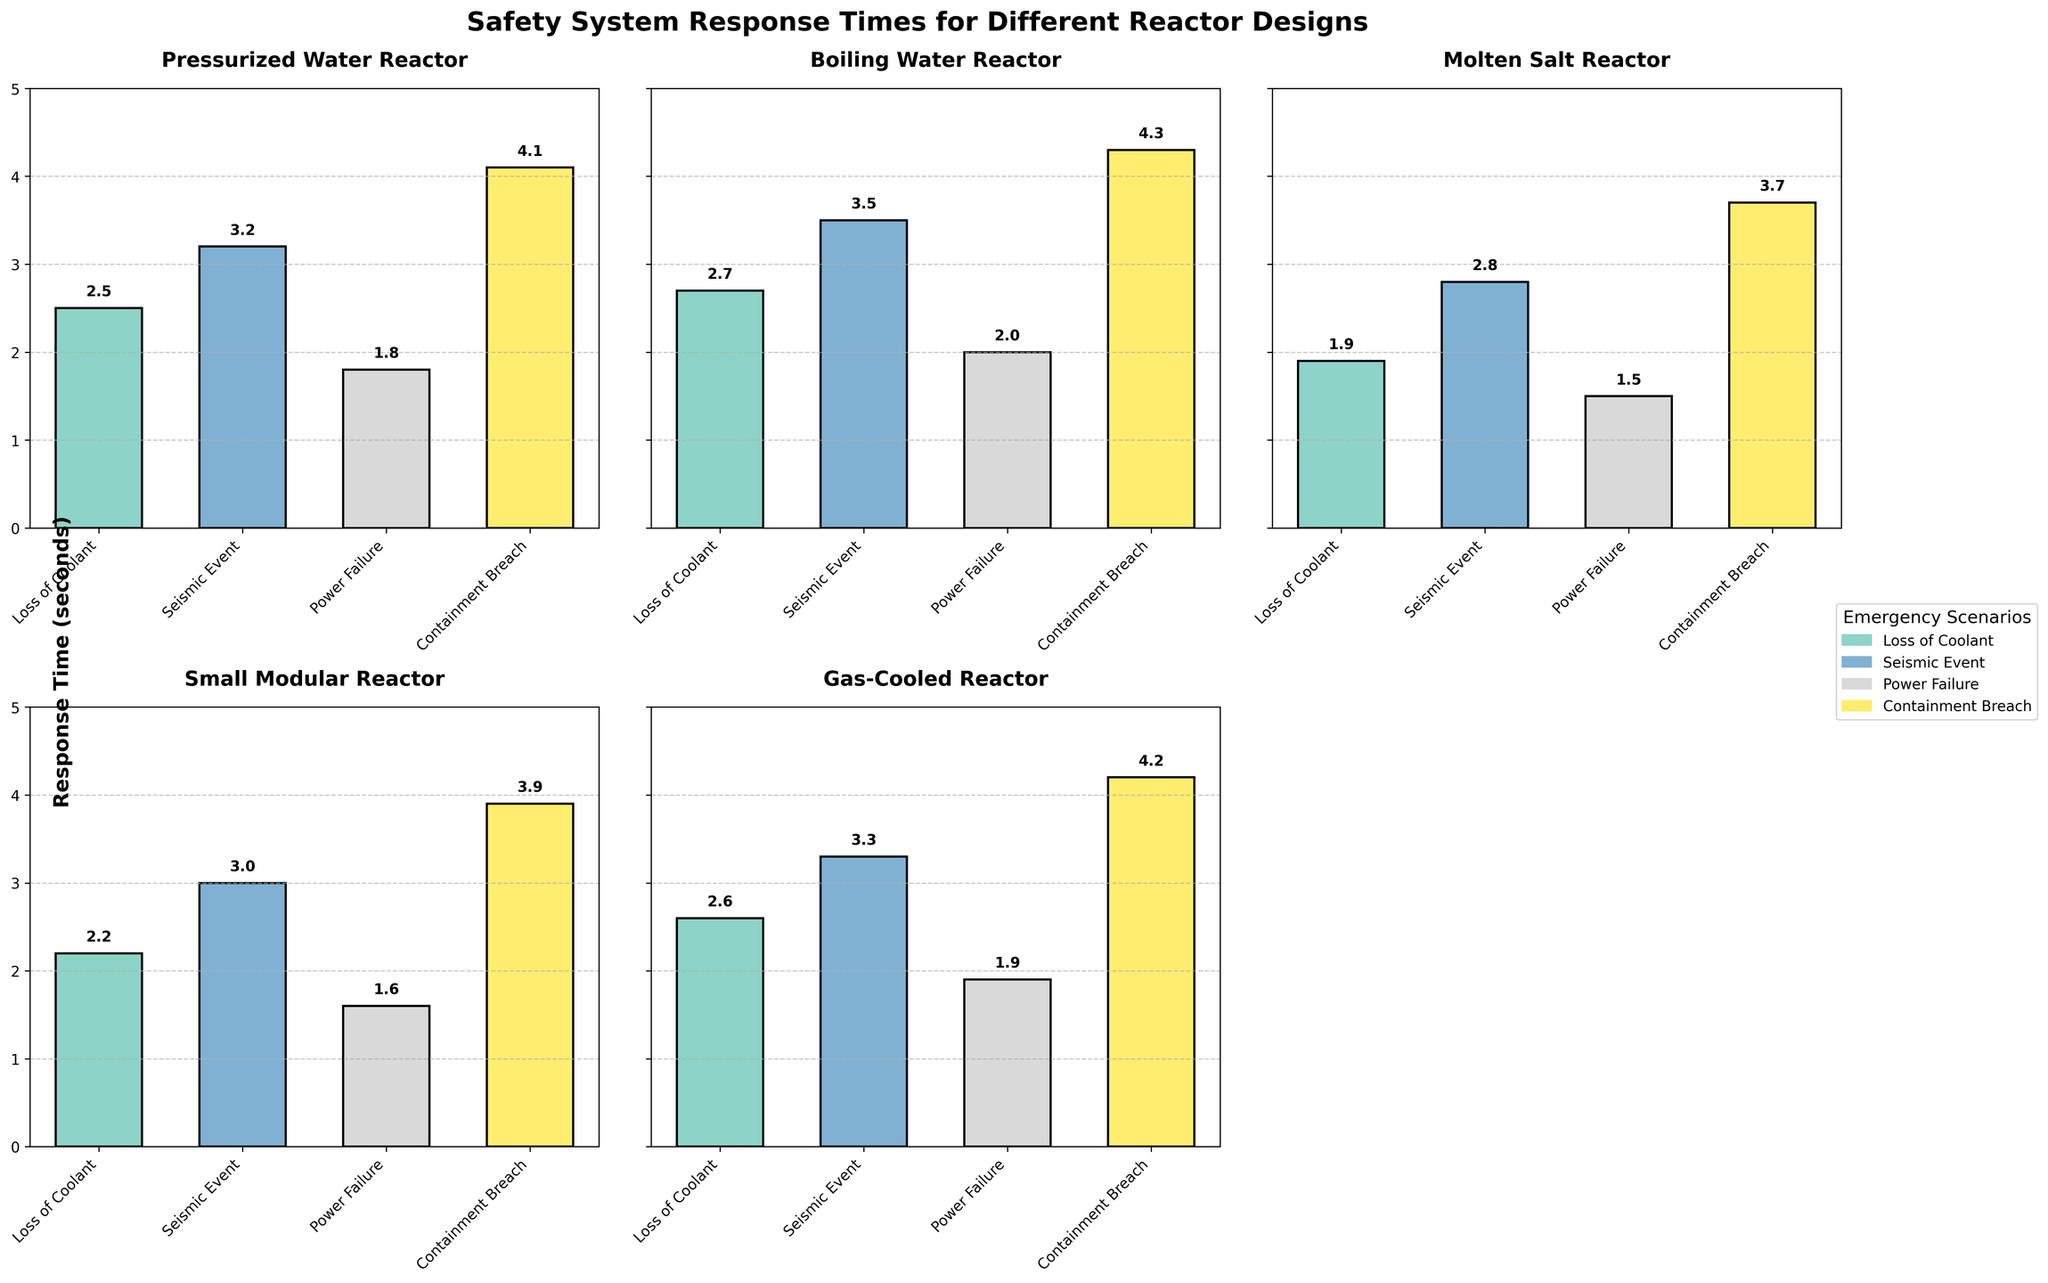Which reactor design has the fastest response time for a loss of coolant scenario? Locate the "Loss of Coolant" bar for each reactor design and find the design with the shortest bar, indicating the lowest response time.
Answer: Molten Salt Reactor Which reactor design has the slowest response time for a containment breach? Find the "Containment Breach" bar for each reactor design and compare their lengths to identify the highest bar, indicating the longest response time.
Answer: Boiling Water Reactor What is the difference in response times between the Seismic Event and Containment Breach scenarios for the Small Modular Reactor? Refer to the Small Modular Reactor subplot, get the heights of the "Seismic Event" and "Containment Breach" bars, and subtract the former from the latter. These heights are 3.0 and 3.9 seconds respectively. Perform the subtraction: 3.9 - 3.0 = 0.9.
Answer: 0.9 seconds Which emergency scenario has the highest overall response time across all reactor designs? Compare the bars labeled for each emergency scenario across all subplots. "Containment Breach" consistently shows the highest bars across the designs.
Answer: Containment Breach What is the average response time for a Power Failure scenario across all reactor designs? Extract the "Power Failure" values from each subplot: 1.8, 2.0, 1.5, 1.6, 1.9, 1.7. Sum these values: 1.8 + 2.0 + 1.5 + 1.6 + 1.9 + 1.7 = 10.5. Divide by the number of reactor designs (6). The average is 10.5 / 6 = 1.75.
Answer: 1.75 seconds How does the response time for a Seismic Event compare between the Pressurized Water Reactor and the Molten Salt Reactor? Locate the "Seismic Event" bars in the Pressurized Water Reactor and Molten Salt Reactor subplots. The heights are 3.2 seconds and 2.8 seconds respectively. Compare the values: 3.2 - 2.8 = 0.4 seconds.
Answer: 0.4 seconds slower for Pressurized Water Reactor Which two reactor designs have the closest response times for a Loss of Coolant? Compare the "Loss of Coolant" bars for all reactor designs: Pressurized Water Reactor (2.5), Boiling Water Reactor (2.7), Molten Salt Reactor (1.9), Small Modular Reactor (2.2), Gas-Cooled Reactor (2.6), Sodium-Cooled Fast Reactor (2.3). The closest values are for Pressurized Water Reactor (2.5) and Gas-Cooled Reactor (2.6), differing by 0.1.
Answer: Pressurized Water Reactor and Gas-Cooled Reactor For which reactor design is the response time for Power Failure exactly halfway between its response times for Seismic Event and Containment Breach? For each reactor design, average the response times for "Seismic Event" and "Containment Breach" and then check if this average equals the "Power Failure" response time: e.g., for Pressurized Water Reactor: (3.2 + 4.1) / 2 = 3.65 ≠ 1.8; do this for each design until you find that for Gas-Cooled Reactor: (3.3 + 4.2) / 2 = 3.75, which does not equal 1.9; for Sodium-Cooled Fast Reactor: (3.1 + 4.0) / 2 = 3.55, which does not equal 1.7. No design matches this criterion.
Answer: None 